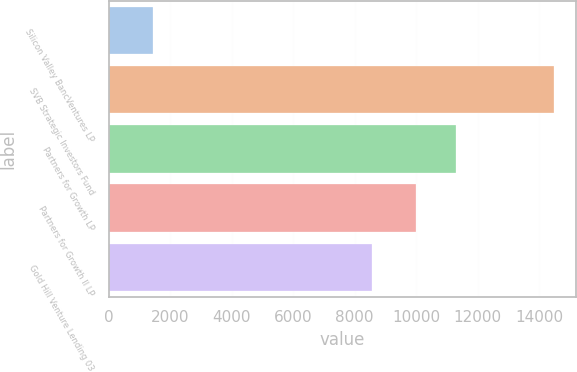<chart> <loc_0><loc_0><loc_500><loc_500><bar_chart><fcel>Silicon Valley BancVentures LP<fcel>SVB Strategic Investors Fund<fcel>Partners for Growth LP<fcel>Partners for Growth II LP<fcel>Gold Hill Venture Lending 03<nl><fcel>1440<fcel>14488<fcel>11304.8<fcel>10000<fcel>8551<nl></chart> 